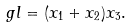Convert formula to latex. <formula><loc_0><loc_0><loc_500><loc_500>\ g l = ( x _ { 1 } + x _ { 2 } ) x _ { 3 } .</formula> 